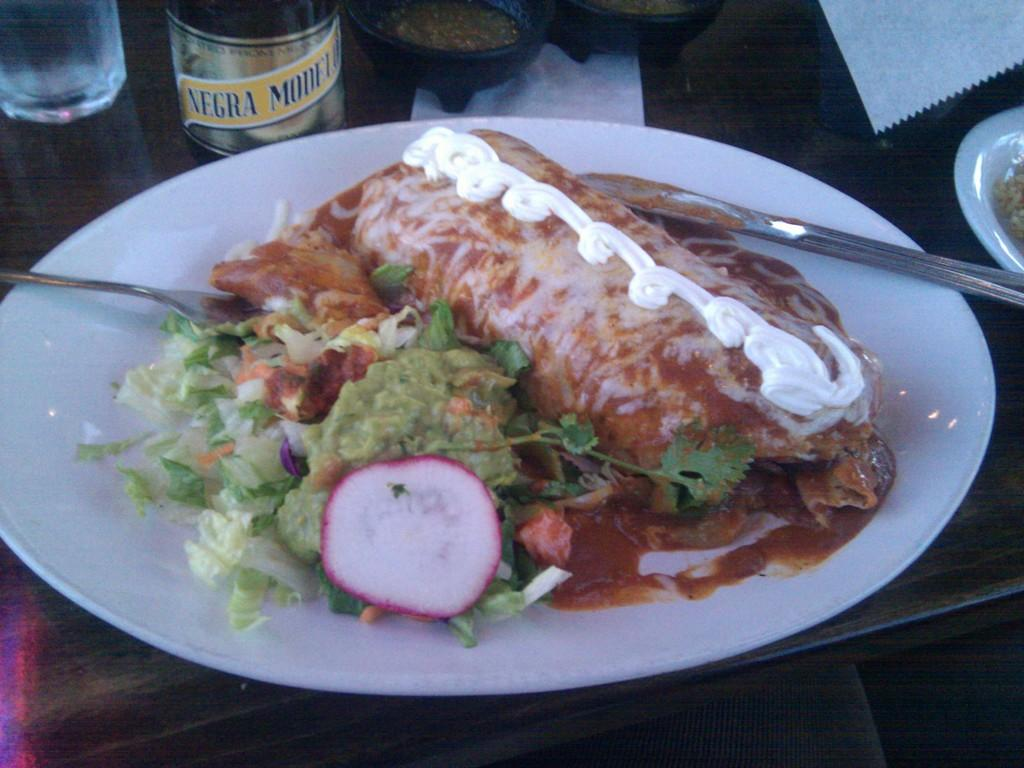What is on the plate in the image? There are food items on a plate in the image. What utensils are visible in the image? There are spoons in the image. What is beside the plate in the image? There is a glass beside the plate in the image. What else can be seen on the table in the image? There are other objects on the table in the image. What type of music is being played in the image? There is no indication of music being played in the image. What color is the curtain behind the table in the image? There is no curtain visible in the image. 